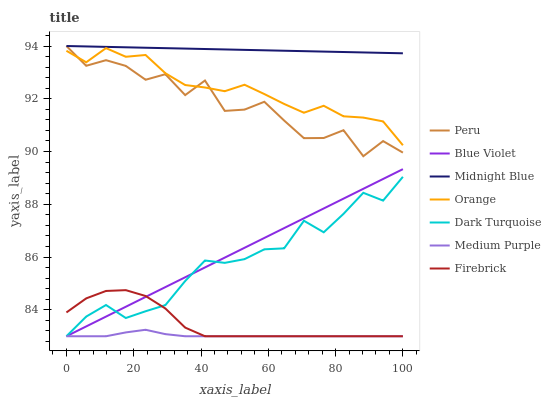Does Medium Purple have the minimum area under the curve?
Answer yes or no. Yes. Does Midnight Blue have the maximum area under the curve?
Answer yes or no. Yes. Does Dark Turquoise have the minimum area under the curve?
Answer yes or no. No. Does Dark Turquoise have the maximum area under the curve?
Answer yes or no. No. Is Blue Violet the smoothest?
Answer yes or no. Yes. Is Peru the roughest?
Answer yes or no. Yes. Is Dark Turquoise the smoothest?
Answer yes or no. No. Is Dark Turquoise the roughest?
Answer yes or no. No. Does Dark Turquoise have the lowest value?
Answer yes or no. Yes. Does Peru have the lowest value?
Answer yes or no. No. Does Peru have the highest value?
Answer yes or no. Yes. Does Dark Turquoise have the highest value?
Answer yes or no. No. Is Blue Violet less than Midnight Blue?
Answer yes or no. Yes. Is Midnight Blue greater than Orange?
Answer yes or no. Yes. Does Medium Purple intersect Firebrick?
Answer yes or no. Yes. Is Medium Purple less than Firebrick?
Answer yes or no. No. Is Medium Purple greater than Firebrick?
Answer yes or no. No. Does Blue Violet intersect Midnight Blue?
Answer yes or no. No. 